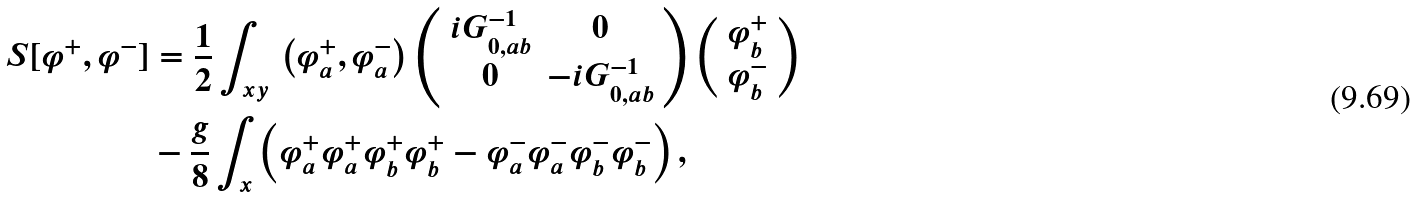<formula> <loc_0><loc_0><loc_500><loc_500>S [ \varphi ^ { + } , \varphi ^ { - } ] & = \frac { 1 } { 2 } \int _ { x y } \, \left ( \varphi ^ { + } _ { a } , \varphi ^ { - } _ { a } \right ) \left ( \begin{array} { c c } i G ^ { - 1 } _ { 0 , a b } & 0 \\ 0 & - i G ^ { - 1 } _ { 0 , a b } \end{array} \right ) \left ( \begin{array} { c } \varphi ^ { + } _ { b } \\ \varphi ^ { - } _ { b } \end{array} \right ) \\ & - \frac { g } { 8 } \int _ { x } \left ( \varphi _ { a } ^ { + } \varphi _ { a } ^ { + } \varphi _ { b } ^ { + } \varphi _ { b } ^ { + } - \varphi _ { a } ^ { - } \varphi _ { a } ^ { - } \varphi _ { b } ^ { - } \varphi _ { b } ^ { - } \right ) ,</formula> 